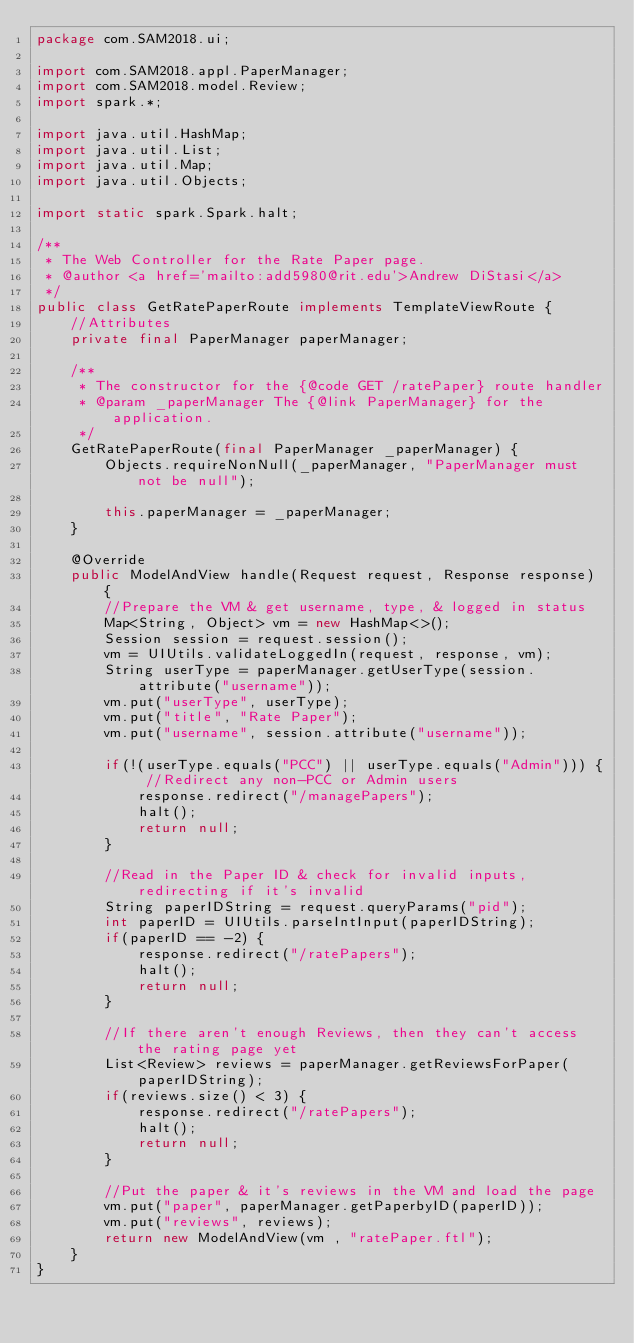Convert code to text. <code><loc_0><loc_0><loc_500><loc_500><_Java_>package com.SAM2018.ui;

import com.SAM2018.appl.PaperManager;
import com.SAM2018.model.Review;
import spark.*;

import java.util.HashMap;
import java.util.List;
import java.util.Map;
import java.util.Objects;

import static spark.Spark.halt;

/**
 * The Web Controller for the Rate Paper page.
 * @author <a href='mailto:add5980@rit.edu'>Andrew DiStasi</a>
 */
public class GetRatePaperRoute implements TemplateViewRoute {
    //Attributes
    private final PaperManager paperManager;

    /**
     * The constructor for the {@code GET /ratePaper} route handler
     * @param _paperManager The {@link PaperManager} for the application.
     */
    GetRatePaperRoute(final PaperManager _paperManager) {
        Objects.requireNonNull(_paperManager, "PaperManager must not be null");

        this.paperManager = _paperManager;
    }

    @Override
    public ModelAndView handle(Request request, Response response) {
        //Prepare the VM & get username, type, & logged in status
        Map<String, Object> vm = new HashMap<>();
        Session session = request.session();
        vm = UIUtils.validateLoggedIn(request, response, vm);
        String userType = paperManager.getUserType(session.attribute("username"));
        vm.put("userType", userType);
        vm.put("title", "Rate Paper");
        vm.put("username", session.attribute("username"));

        if(!(userType.equals("PCC") || userType.equals("Admin"))) { //Redirect any non-PCC or Admin users
            response.redirect("/managePapers");
            halt();
            return null;
        }

        //Read in the Paper ID & check for invalid inputs, redirecting if it's invalid
        String paperIDString = request.queryParams("pid");
        int paperID = UIUtils.parseIntInput(paperIDString);
        if(paperID == -2) {
            response.redirect("/ratePapers");
            halt();
            return null;
        }

        //If there aren't enough Reviews, then they can't access the rating page yet
        List<Review> reviews = paperManager.getReviewsForPaper(paperIDString);
        if(reviews.size() < 3) {
            response.redirect("/ratePapers");
            halt();
            return null;
        }

        //Put the paper & it's reviews in the VM and load the page
        vm.put("paper", paperManager.getPaperbyID(paperID));
        vm.put("reviews", reviews);
        return new ModelAndView(vm , "ratePaper.ftl");
    }
}
</code> 